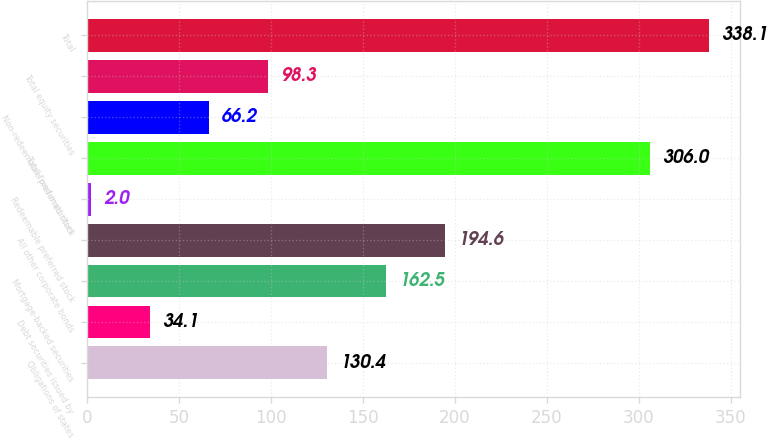Convert chart. <chart><loc_0><loc_0><loc_500><loc_500><bar_chart><fcel>Obligations of states<fcel>Debt securities issued by<fcel>Mortgage-backed securities<fcel>All other corporate bonds<fcel>Redeemable preferred stock<fcel>Total fixed maturities<fcel>Non-redeemable preferred stock<fcel>Total equity securities<fcel>Total<nl><fcel>130.4<fcel>34.1<fcel>162.5<fcel>194.6<fcel>2<fcel>306<fcel>66.2<fcel>98.3<fcel>338.1<nl></chart> 